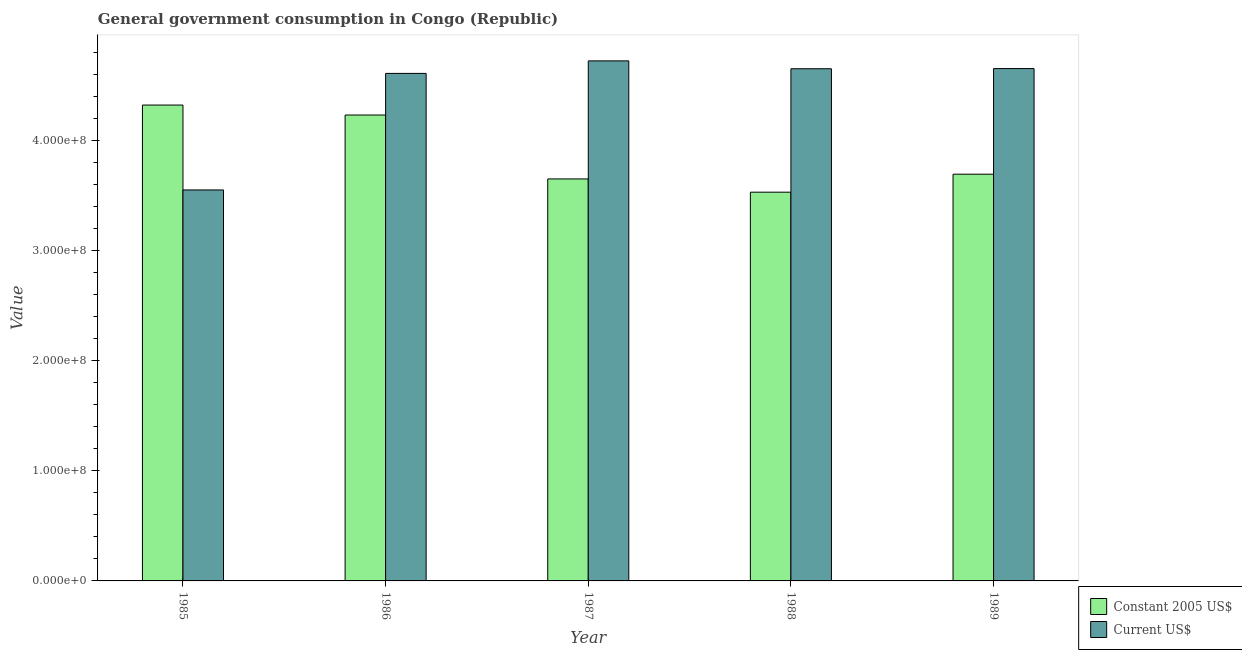How many different coloured bars are there?
Ensure brevity in your answer.  2. How many groups of bars are there?
Your answer should be compact. 5. How many bars are there on the 1st tick from the left?
Give a very brief answer. 2. How many bars are there on the 4th tick from the right?
Provide a succinct answer. 2. What is the label of the 5th group of bars from the left?
Offer a very short reply. 1989. What is the value consumed in constant 2005 us$ in 1988?
Provide a short and direct response. 3.53e+08. Across all years, what is the maximum value consumed in current us$?
Offer a very short reply. 4.73e+08. Across all years, what is the minimum value consumed in current us$?
Keep it short and to the point. 3.55e+08. In which year was the value consumed in current us$ maximum?
Ensure brevity in your answer.  1987. What is the total value consumed in constant 2005 us$ in the graph?
Give a very brief answer. 1.94e+09. What is the difference between the value consumed in constant 2005 us$ in 1987 and that in 1989?
Your answer should be compact. -4.31e+06. What is the difference between the value consumed in current us$ in 1986 and the value consumed in constant 2005 us$ in 1987?
Keep it short and to the point. -1.14e+07. What is the average value consumed in current us$ per year?
Provide a succinct answer. 4.44e+08. In the year 1989, what is the difference between the value consumed in constant 2005 us$ and value consumed in current us$?
Provide a short and direct response. 0. In how many years, is the value consumed in current us$ greater than 40000000?
Provide a short and direct response. 5. What is the ratio of the value consumed in current us$ in 1986 to that in 1987?
Provide a short and direct response. 0.98. What is the difference between the highest and the second highest value consumed in constant 2005 us$?
Your answer should be very brief. 9.04e+06. What is the difference between the highest and the lowest value consumed in constant 2005 us$?
Offer a terse response. 7.92e+07. In how many years, is the value consumed in current us$ greater than the average value consumed in current us$ taken over all years?
Keep it short and to the point. 4. Is the sum of the value consumed in current us$ in 1985 and 1989 greater than the maximum value consumed in constant 2005 us$ across all years?
Your answer should be very brief. Yes. What does the 1st bar from the left in 1989 represents?
Make the answer very short. Constant 2005 US$. What does the 2nd bar from the right in 1986 represents?
Offer a terse response. Constant 2005 US$. Are the values on the major ticks of Y-axis written in scientific E-notation?
Offer a very short reply. Yes. Does the graph contain grids?
Make the answer very short. No. Where does the legend appear in the graph?
Make the answer very short. Bottom right. How are the legend labels stacked?
Offer a terse response. Vertical. What is the title of the graph?
Keep it short and to the point. General government consumption in Congo (Republic). Does "Netherlands" appear as one of the legend labels in the graph?
Provide a succinct answer. No. What is the label or title of the Y-axis?
Your answer should be compact. Value. What is the Value of Constant 2005 US$ in 1985?
Provide a short and direct response. 4.33e+08. What is the Value in Current US$ in 1985?
Your answer should be compact. 3.55e+08. What is the Value of Constant 2005 US$ in 1986?
Your answer should be very brief. 4.24e+08. What is the Value in Current US$ in 1986?
Give a very brief answer. 4.61e+08. What is the Value in Constant 2005 US$ in 1987?
Your response must be concise. 3.65e+08. What is the Value in Current US$ in 1987?
Your answer should be compact. 4.73e+08. What is the Value in Constant 2005 US$ in 1988?
Offer a very short reply. 3.53e+08. What is the Value in Current US$ in 1988?
Keep it short and to the point. 4.66e+08. What is the Value in Constant 2005 US$ in 1989?
Make the answer very short. 3.70e+08. What is the Value of Current US$ in 1989?
Your answer should be very brief. 4.66e+08. Across all years, what is the maximum Value of Constant 2005 US$?
Make the answer very short. 4.33e+08. Across all years, what is the maximum Value in Current US$?
Your response must be concise. 4.73e+08. Across all years, what is the minimum Value of Constant 2005 US$?
Offer a terse response. 3.53e+08. Across all years, what is the minimum Value in Current US$?
Keep it short and to the point. 3.55e+08. What is the total Value of Constant 2005 US$ in the graph?
Your answer should be very brief. 1.94e+09. What is the total Value in Current US$ in the graph?
Provide a short and direct response. 2.22e+09. What is the difference between the Value of Constant 2005 US$ in 1985 and that in 1986?
Provide a succinct answer. 9.04e+06. What is the difference between the Value of Current US$ in 1985 and that in 1986?
Your answer should be very brief. -1.06e+08. What is the difference between the Value in Constant 2005 US$ in 1985 and that in 1987?
Offer a very short reply. 6.72e+07. What is the difference between the Value of Current US$ in 1985 and that in 1987?
Make the answer very short. -1.17e+08. What is the difference between the Value in Constant 2005 US$ in 1985 and that in 1988?
Your answer should be compact. 7.92e+07. What is the difference between the Value in Current US$ in 1985 and that in 1988?
Your response must be concise. -1.10e+08. What is the difference between the Value of Constant 2005 US$ in 1985 and that in 1989?
Your response must be concise. 6.29e+07. What is the difference between the Value of Current US$ in 1985 and that in 1989?
Give a very brief answer. -1.10e+08. What is the difference between the Value of Constant 2005 US$ in 1986 and that in 1987?
Your answer should be compact. 5.81e+07. What is the difference between the Value of Current US$ in 1986 and that in 1987?
Ensure brevity in your answer.  -1.14e+07. What is the difference between the Value in Constant 2005 US$ in 1986 and that in 1988?
Offer a very short reply. 7.02e+07. What is the difference between the Value in Current US$ in 1986 and that in 1988?
Your answer should be compact. -4.23e+06. What is the difference between the Value in Constant 2005 US$ in 1986 and that in 1989?
Provide a short and direct response. 5.38e+07. What is the difference between the Value in Current US$ in 1986 and that in 1989?
Your answer should be compact. -4.38e+06. What is the difference between the Value of Constant 2005 US$ in 1987 and that in 1988?
Give a very brief answer. 1.21e+07. What is the difference between the Value of Current US$ in 1987 and that in 1988?
Your answer should be very brief. 7.15e+06. What is the difference between the Value in Constant 2005 US$ in 1987 and that in 1989?
Offer a terse response. -4.31e+06. What is the difference between the Value of Current US$ in 1987 and that in 1989?
Ensure brevity in your answer.  7.00e+06. What is the difference between the Value of Constant 2005 US$ in 1988 and that in 1989?
Give a very brief answer. -1.64e+07. What is the difference between the Value of Current US$ in 1988 and that in 1989?
Make the answer very short. -1.45e+05. What is the difference between the Value in Constant 2005 US$ in 1985 and the Value in Current US$ in 1986?
Your answer should be very brief. -2.88e+07. What is the difference between the Value of Constant 2005 US$ in 1985 and the Value of Current US$ in 1987?
Give a very brief answer. -4.02e+07. What is the difference between the Value of Constant 2005 US$ in 1985 and the Value of Current US$ in 1988?
Your response must be concise. -3.30e+07. What is the difference between the Value in Constant 2005 US$ in 1985 and the Value in Current US$ in 1989?
Keep it short and to the point. -3.32e+07. What is the difference between the Value in Constant 2005 US$ in 1986 and the Value in Current US$ in 1987?
Offer a very short reply. -4.92e+07. What is the difference between the Value in Constant 2005 US$ in 1986 and the Value in Current US$ in 1988?
Offer a very short reply. -4.21e+07. What is the difference between the Value in Constant 2005 US$ in 1986 and the Value in Current US$ in 1989?
Offer a terse response. -4.22e+07. What is the difference between the Value of Constant 2005 US$ in 1987 and the Value of Current US$ in 1988?
Your answer should be very brief. -1.00e+08. What is the difference between the Value in Constant 2005 US$ in 1987 and the Value in Current US$ in 1989?
Ensure brevity in your answer.  -1.00e+08. What is the difference between the Value in Constant 2005 US$ in 1988 and the Value in Current US$ in 1989?
Provide a short and direct response. -1.12e+08. What is the average Value of Constant 2005 US$ per year?
Provide a short and direct response. 3.89e+08. What is the average Value of Current US$ per year?
Give a very brief answer. 4.44e+08. In the year 1985, what is the difference between the Value in Constant 2005 US$ and Value in Current US$?
Offer a terse response. 7.72e+07. In the year 1986, what is the difference between the Value in Constant 2005 US$ and Value in Current US$?
Ensure brevity in your answer.  -3.78e+07. In the year 1987, what is the difference between the Value of Constant 2005 US$ and Value of Current US$?
Your answer should be very brief. -1.07e+08. In the year 1988, what is the difference between the Value of Constant 2005 US$ and Value of Current US$?
Your answer should be very brief. -1.12e+08. In the year 1989, what is the difference between the Value in Constant 2005 US$ and Value in Current US$?
Your response must be concise. -9.60e+07. What is the ratio of the Value in Constant 2005 US$ in 1985 to that in 1986?
Your answer should be compact. 1.02. What is the ratio of the Value in Current US$ in 1985 to that in 1986?
Ensure brevity in your answer.  0.77. What is the ratio of the Value in Constant 2005 US$ in 1985 to that in 1987?
Ensure brevity in your answer.  1.18. What is the ratio of the Value in Current US$ in 1985 to that in 1987?
Provide a succinct answer. 0.75. What is the ratio of the Value in Constant 2005 US$ in 1985 to that in 1988?
Provide a succinct answer. 1.22. What is the ratio of the Value of Current US$ in 1985 to that in 1988?
Provide a short and direct response. 0.76. What is the ratio of the Value in Constant 2005 US$ in 1985 to that in 1989?
Make the answer very short. 1.17. What is the ratio of the Value in Current US$ in 1985 to that in 1989?
Make the answer very short. 0.76. What is the ratio of the Value of Constant 2005 US$ in 1986 to that in 1987?
Offer a terse response. 1.16. What is the ratio of the Value of Current US$ in 1986 to that in 1987?
Keep it short and to the point. 0.98. What is the ratio of the Value of Constant 2005 US$ in 1986 to that in 1988?
Ensure brevity in your answer.  1.2. What is the ratio of the Value in Current US$ in 1986 to that in 1988?
Your answer should be compact. 0.99. What is the ratio of the Value in Constant 2005 US$ in 1986 to that in 1989?
Offer a terse response. 1.15. What is the ratio of the Value of Current US$ in 1986 to that in 1989?
Your answer should be compact. 0.99. What is the ratio of the Value of Constant 2005 US$ in 1987 to that in 1988?
Provide a succinct answer. 1.03. What is the ratio of the Value of Current US$ in 1987 to that in 1988?
Your answer should be compact. 1.02. What is the ratio of the Value in Constant 2005 US$ in 1987 to that in 1989?
Offer a very short reply. 0.99. What is the ratio of the Value of Current US$ in 1987 to that in 1989?
Provide a succinct answer. 1.01. What is the ratio of the Value of Constant 2005 US$ in 1988 to that in 1989?
Provide a succinct answer. 0.96. What is the ratio of the Value in Current US$ in 1988 to that in 1989?
Offer a terse response. 1. What is the difference between the highest and the second highest Value of Constant 2005 US$?
Offer a terse response. 9.04e+06. What is the difference between the highest and the second highest Value of Current US$?
Offer a very short reply. 7.00e+06. What is the difference between the highest and the lowest Value of Constant 2005 US$?
Provide a succinct answer. 7.92e+07. What is the difference between the highest and the lowest Value in Current US$?
Your answer should be very brief. 1.17e+08. 